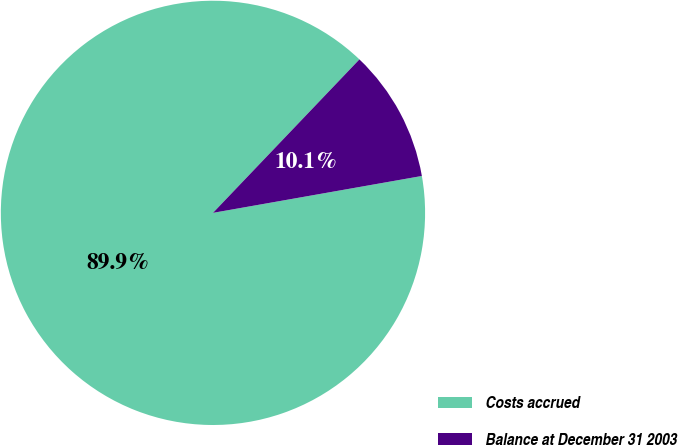Convert chart. <chart><loc_0><loc_0><loc_500><loc_500><pie_chart><fcel>Costs accrued<fcel>Balance at December 31 2003<nl><fcel>89.91%<fcel>10.09%<nl></chart> 